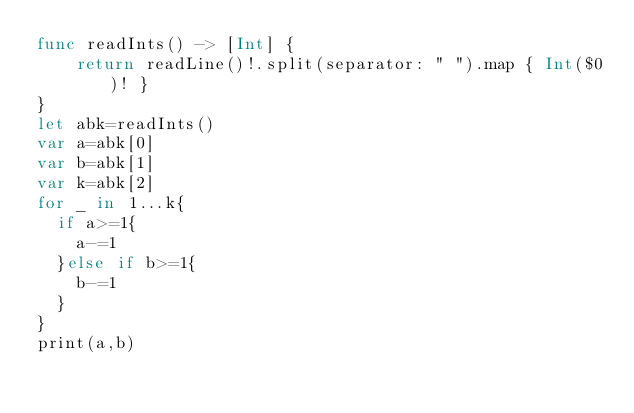<code> <loc_0><loc_0><loc_500><loc_500><_Swift_>func readInts() -> [Int] {
    return readLine()!.split(separator: " ").map { Int($0)! }
}
let abk=readInts()
var a=abk[0]
var b=abk[1]
var k=abk[2]
for _ in 1...k{
  if a>=1{
    a-=1
  }else if b>=1{
    b-=1
  }
}
print(a,b)

</code> 